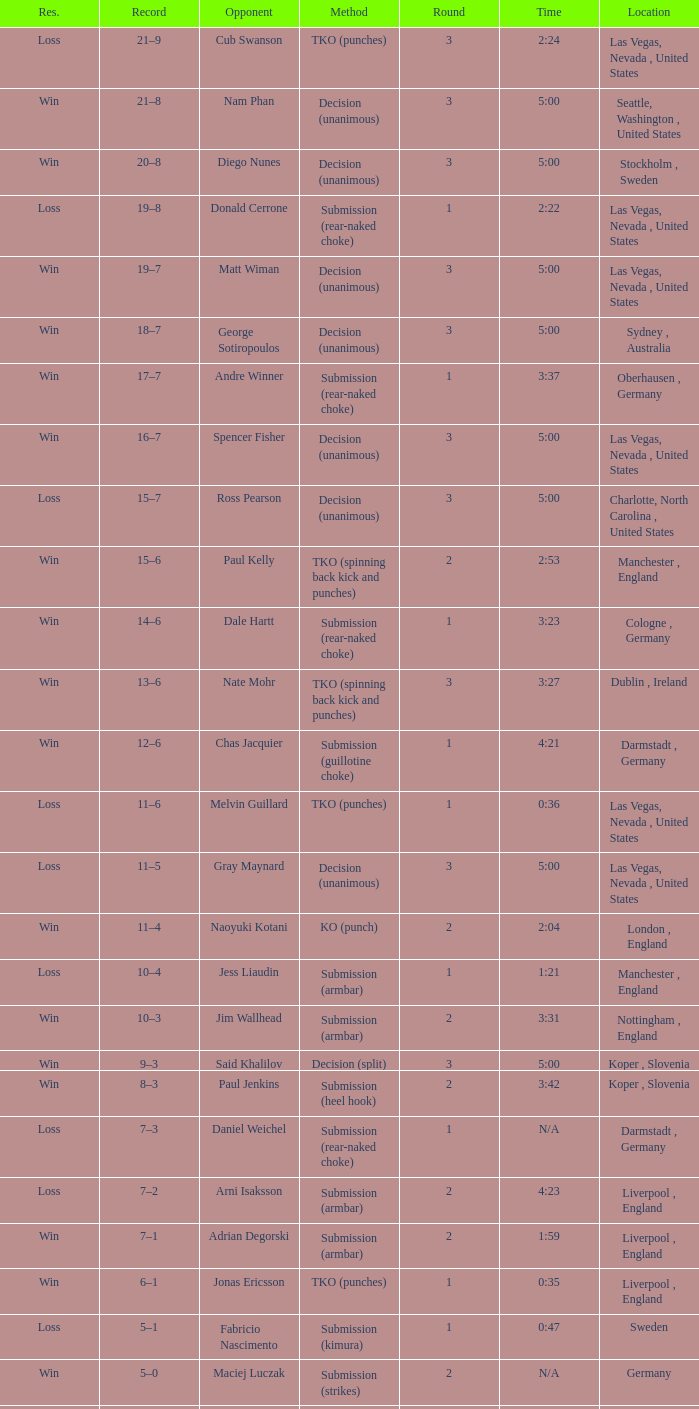What was the approach of resolution for the battle against dale hartt? Submission (rear-naked choke). 